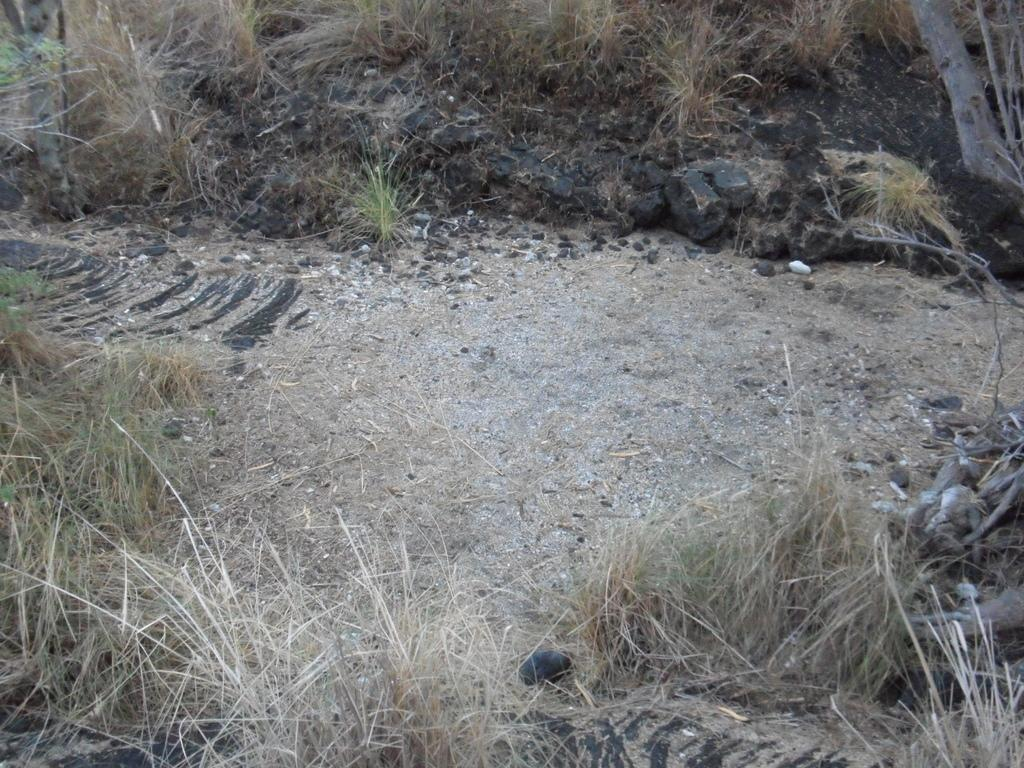What type of terrain is depicted in the image? There is a land with dried grass in the image. What other elements can be seen on the land? Stones are present in the image. What part of a tree is visible in the image? The bark of a tree is visible in the image. What type of animal is sitting on the stone in the image? There is no animal present in the image; it only shows a land with dried grass, stones, and the bark of a tree. How many apples can be seen on the tree in the image? There is no tree with apples in the image; it only shows the bark of a tree. 